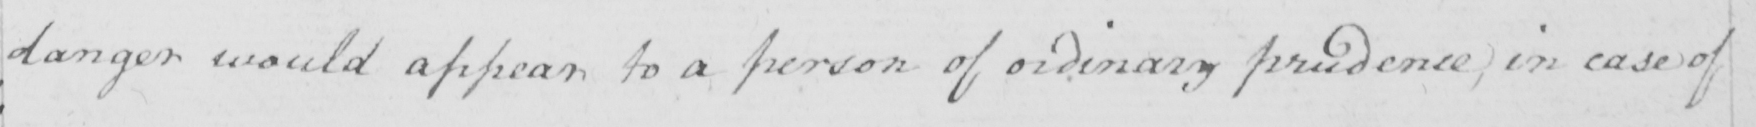Please transcribe the handwritten text in this image. danger would appear to a person of ordinary prudence ; in case of 